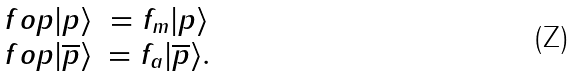Convert formula to latex. <formula><loc_0><loc_0><loc_500><loc_500>\begin{array} { r c l } \ f o p | p \rangle & = f _ { m } | p \rangle \\ \ f o p | \overline { p } \rangle & = f _ { a } | \overline { p } \rangle . \end{array}</formula> 